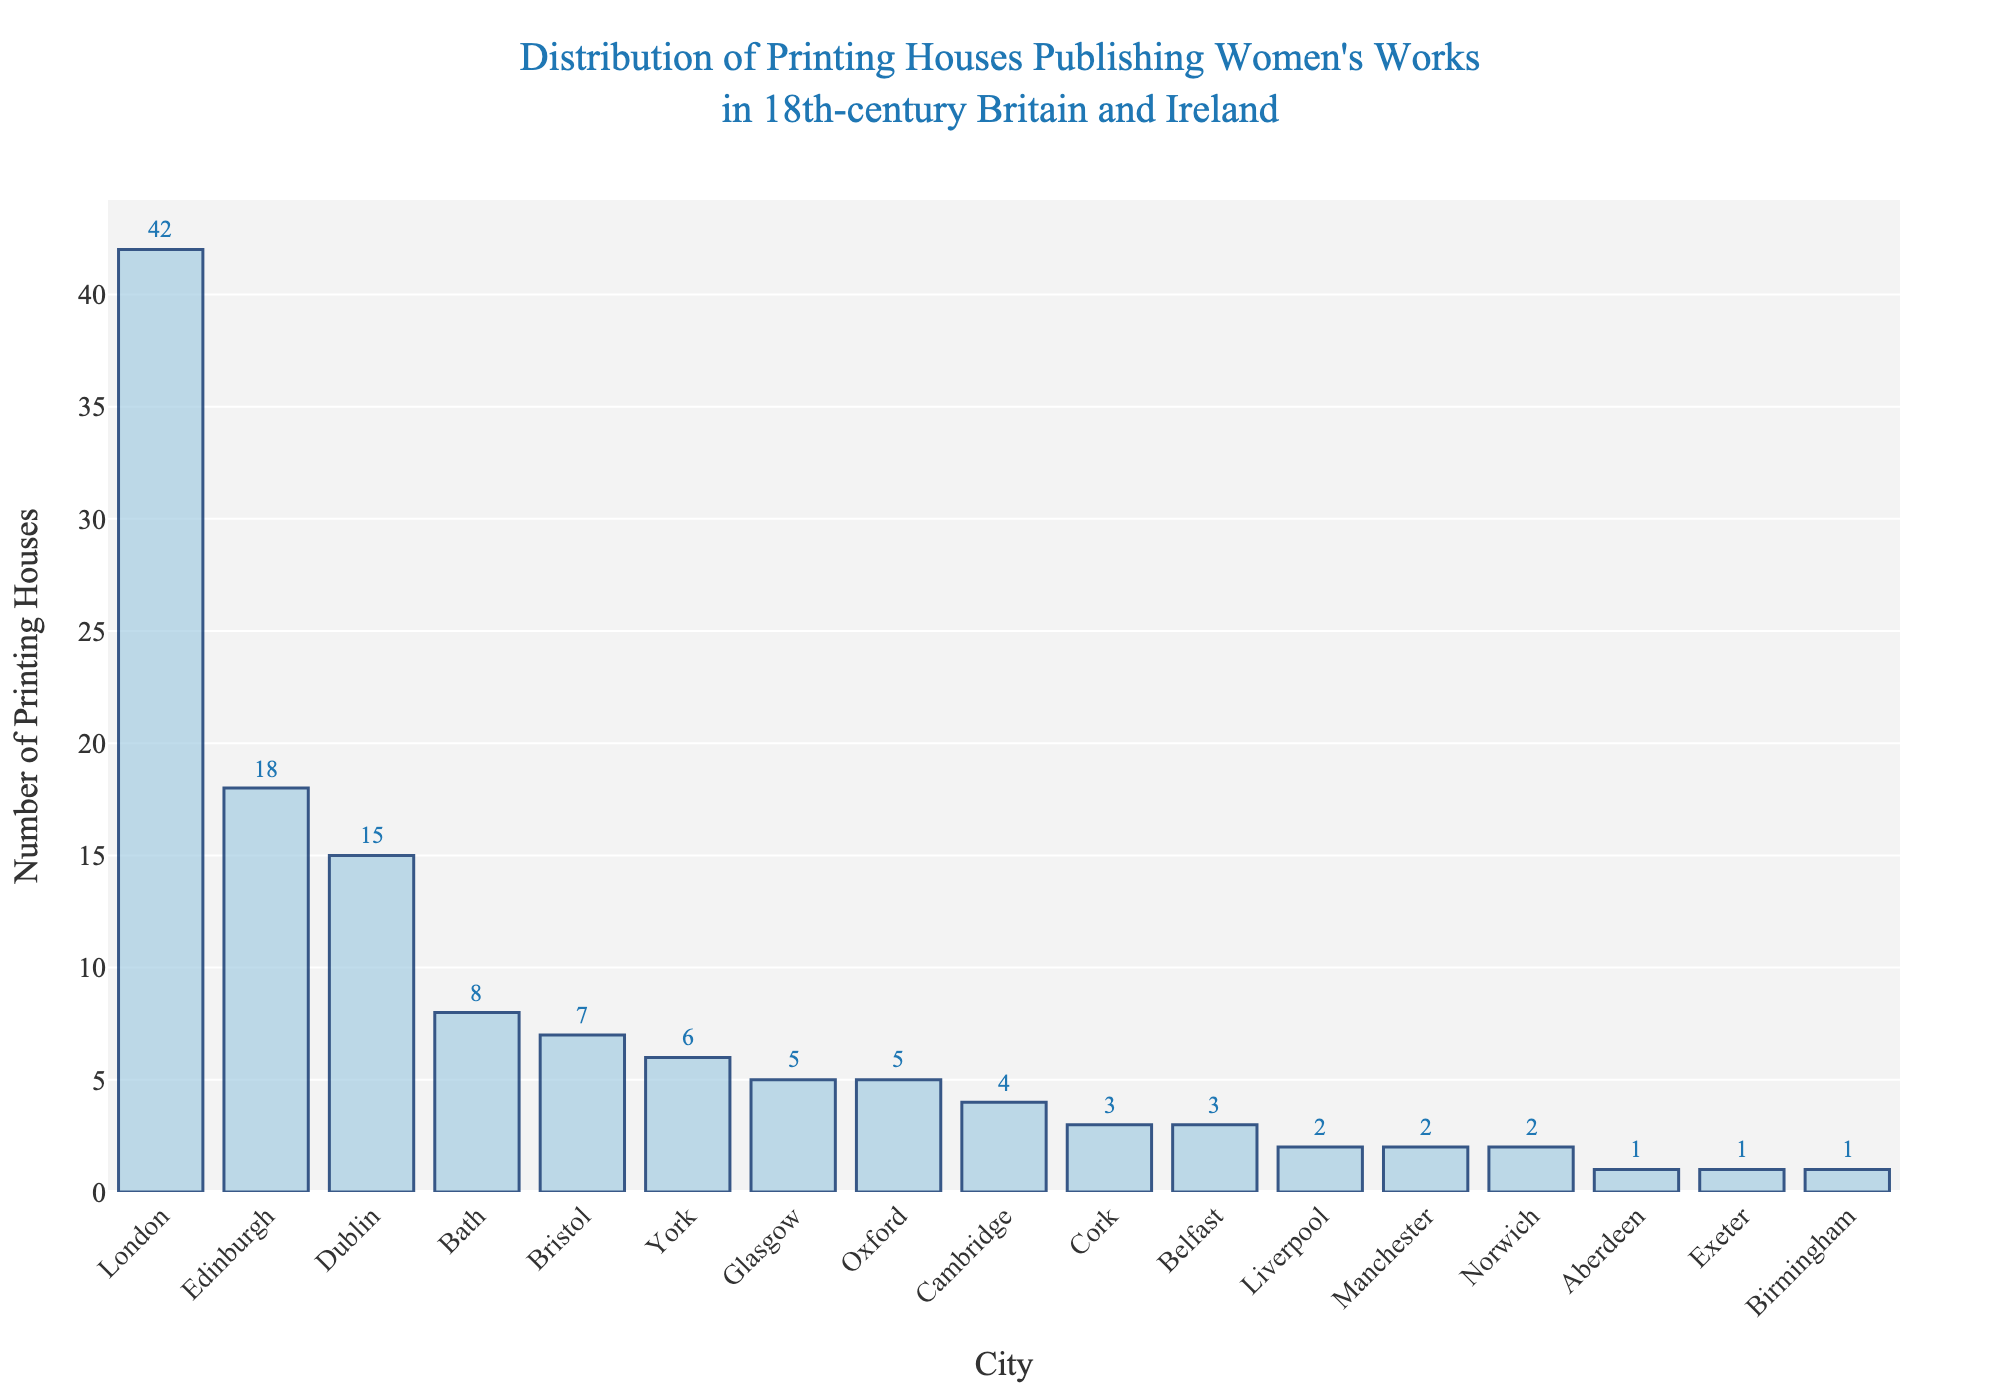1. What city has the highest number of printing houses? To identify the city with the highest number of printing houses, look for the tallest bar in the chart. The bar representing London is the tallest with 42 printing houses.
Answer: London 2. How many more printing houses are there in Edinburgh compared to Bath? Edinburgh has 18 printing houses, and Bath has 8. Subtract the number of printing houses in Bath from those in Edinburgh (18 - 8).
Answer: 10 3. Which cities have an equal number of printing houses? Scan the chart for bars of the same height. Both Glasgow and Oxford have 5 printing houses each, and Cork and Belfast have 3 printing houses each.
Answer: Glasgow and Oxford, Cork and Belfast 4. Is the number of printing houses in Dublin greater than in Bristol? Compare the heights of the bars for Dublin and Bristol. Dublin has 15 printing houses, while Bristol has 7, so Dublin has more.
Answer: Yes 5. What is the total number of printing houses in the top three cities combined? Sum the number of printing houses in the top three cities: London (42), Edinburgh (18), and Dublin (15). The total is 42 + 18 + 15.
Answer: 75 6. How many cities have more than 5 printing houses? Identify the cities where the number of printing houses is greater than 5. These cities are London, Edinburgh, Dublin, Bath, and Bristol. This makes 5 cities.
Answer: 5 7. Which city has the second highest number of printing houses? The second tallest bar after London (42) represents Edinburgh with 18 printing houses.
Answer: Edinburgh 8. Are there any cities with only 1 printing house? Check for the bars with the lowest height, indicating only 1 printing house. Aberdeen, Exeter, and Birmingham each have 1 printing house.
Answer: Yes 9. How does the number of printing houses in York compare to those in Glasgow? York has 6 printing houses, and Glasgow has 5. Since 6 is greater than 5, York has more printing houses than Glasgow.
Answer: York has more 10. What is the difference in the number of printing houses between Cork and Norwich? Cork has 3 printing houses, and Norwich has 2. Subtract the number of printing houses in Norwich from those in Cork (3 - 2).
Answer: 1 